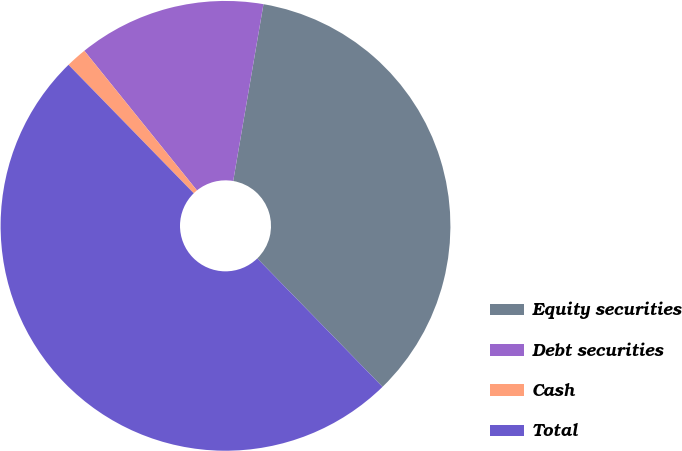<chart> <loc_0><loc_0><loc_500><loc_500><pie_chart><fcel>Equity securities<fcel>Debt securities<fcel>Cash<fcel>Total<nl><fcel>35.0%<fcel>13.5%<fcel>1.5%<fcel>50.0%<nl></chart> 